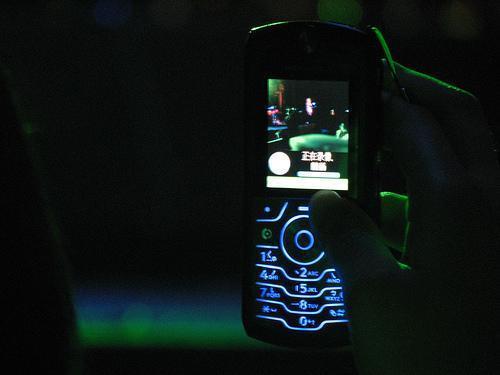How many blue circles are on the phone?
Give a very brief answer. 2. How many phone buttons are green?
Give a very brief answer. 1. 